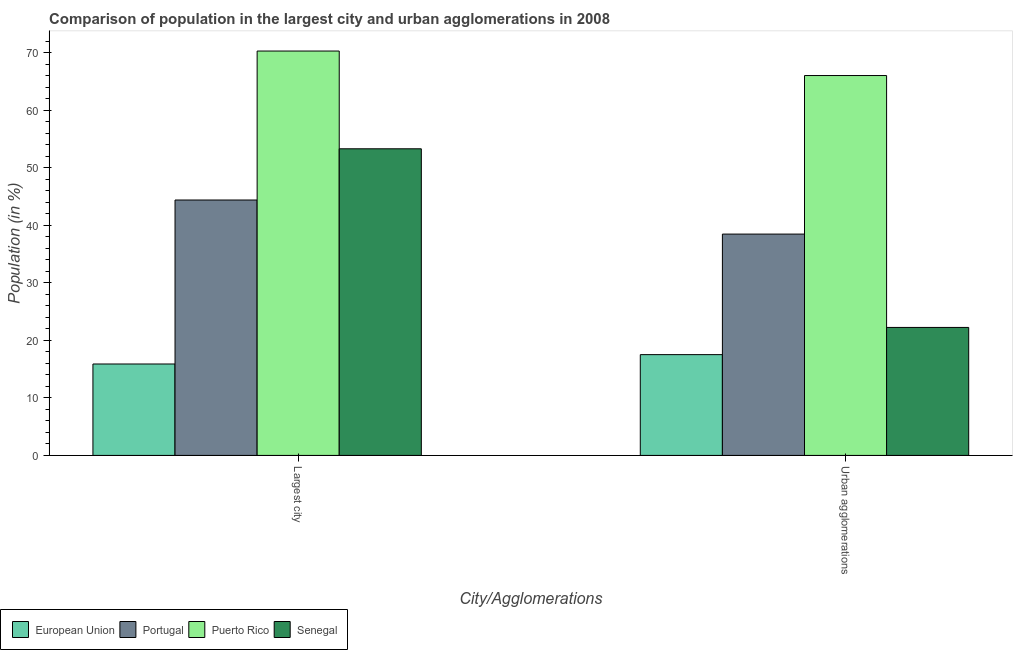How many different coloured bars are there?
Provide a succinct answer. 4. Are the number of bars per tick equal to the number of legend labels?
Keep it short and to the point. Yes. How many bars are there on the 1st tick from the left?
Ensure brevity in your answer.  4. What is the label of the 2nd group of bars from the left?
Provide a succinct answer. Urban agglomerations. What is the population in urban agglomerations in European Union?
Give a very brief answer. 17.52. Across all countries, what is the maximum population in the largest city?
Keep it short and to the point. 70.31. Across all countries, what is the minimum population in the largest city?
Provide a short and direct response. 15.9. In which country was the population in the largest city maximum?
Keep it short and to the point. Puerto Rico. What is the total population in urban agglomerations in the graph?
Offer a very short reply. 144.32. What is the difference between the population in urban agglomerations in Senegal and that in Portugal?
Keep it short and to the point. -16.23. What is the difference between the population in urban agglomerations in Senegal and the population in the largest city in European Union?
Offer a terse response. 6.36. What is the average population in urban agglomerations per country?
Your answer should be very brief. 36.08. What is the difference between the population in the largest city and population in urban agglomerations in Senegal?
Provide a short and direct response. 31.06. In how many countries, is the population in the largest city greater than 26 %?
Provide a succinct answer. 3. What is the ratio of the population in urban agglomerations in European Union to that in Portugal?
Your answer should be compact. 0.46. In how many countries, is the population in urban agglomerations greater than the average population in urban agglomerations taken over all countries?
Your answer should be compact. 2. What does the 1st bar from the right in Largest city represents?
Provide a succinct answer. Senegal. How many bars are there?
Ensure brevity in your answer.  8. Are all the bars in the graph horizontal?
Offer a terse response. No. What is the difference between two consecutive major ticks on the Y-axis?
Give a very brief answer. 10. Are the values on the major ticks of Y-axis written in scientific E-notation?
Provide a short and direct response. No. Does the graph contain any zero values?
Provide a short and direct response. No. What is the title of the graph?
Your response must be concise. Comparison of population in the largest city and urban agglomerations in 2008. What is the label or title of the X-axis?
Offer a very short reply. City/Agglomerations. What is the Population (in %) in European Union in Largest city?
Your answer should be compact. 15.9. What is the Population (in %) of Portugal in Largest city?
Offer a terse response. 44.41. What is the Population (in %) in Puerto Rico in Largest city?
Your answer should be very brief. 70.31. What is the Population (in %) in Senegal in Largest city?
Provide a short and direct response. 53.32. What is the Population (in %) in European Union in Urban agglomerations?
Offer a terse response. 17.52. What is the Population (in %) in Portugal in Urban agglomerations?
Provide a succinct answer. 38.49. What is the Population (in %) of Puerto Rico in Urban agglomerations?
Give a very brief answer. 66.05. What is the Population (in %) of Senegal in Urban agglomerations?
Your response must be concise. 22.25. Across all City/Agglomerations, what is the maximum Population (in %) in European Union?
Make the answer very short. 17.52. Across all City/Agglomerations, what is the maximum Population (in %) of Portugal?
Your response must be concise. 44.41. Across all City/Agglomerations, what is the maximum Population (in %) in Puerto Rico?
Your response must be concise. 70.31. Across all City/Agglomerations, what is the maximum Population (in %) in Senegal?
Your response must be concise. 53.32. Across all City/Agglomerations, what is the minimum Population (in %) of European Union?
Provide a short and direct response. 15.9. Across all City/Agglomerations, what is the minimum Population (in %) of Portugal?
Your response must be concise. 38.49. Across all City/Agglomerations, what is the minimum Population (in %) in Puerto Rico?
Your response must be concise. 66.05. Across all City/Agglomerations, what is the minimum Population (in %) in Senegal?
Your answer should be very brief. 22.25. What is the total Population (in %) of European Union in the graph?
Your answer should be compact. 33.42. What is the total Population (in %) of Portugal in the graph?
Your response must be concise. 82.9. What is the total Population (in %) in Puerto Rico in the graph?
Your answer should be compact. 136.36. What is the total Population (in %) of Senegal in the graph?
Keep it short and to the point. 75.57. What is the difference between the Population (in %) of European Union in Largest city and that in Urban agglomerations?
Offer a terse response. -1.63. What is the difference between the Population (in %) of Portugal in Largest city and that in Urban agglomerations?
Keep it short and to the point. 5.93. What is the difference between the Population (in %) of Puerto Rico in Largest city and that in Urban agglomerations?
Give a very brief answer. 4.26. What is the difference between the Population (in %) of Senegal in Largest city and that in Urban agglomerations?
Your answer should be compact. 31.06. What is the difference between the Population (in %) in European Union in Largest city and the Population (in %) in Portugal in Urban agglomerations?
Ensure brevity in your answer.  -22.59. What is the difference between the Population (in %) in European Union in Largest city and the Population (in %) in Puerto Rico in Urban agglomerations?
Ensure brevity in your answer.  -50.15. What is the difference between the Population (in %) in European Union in Largest city and the Population (in %) in Senegal in Urban agglomerations?
Make the answer very short. -6.36. What is the difference between the Population (in %) of Portugal in Largest city and the Population (in %) of Puerto Rico in Urban agglomerations?
Provide a succinct answer. -21.64. What is the difference between the Population (in %) in Portugal in Largest city and the Population (in %) in Senegal in Urban agglomerations?
Make the answer very short. 22.16. What is the difference between the Population (in %) of Puerto Rico in Largest city and the Population (in %) of Senegal in Urban agglomerations?
Keep it short and to the point. 48.06. What is the average Population (in %) of European Union per City/Agglomerations?
Offer a very short reply. 16.71. What is the average Population (in %) of Portugal per City/Agglomerations?
Offer a very short reply. 41.45. What is the average Population (in %) in Puerto Rico per City/Agglomerations?
Your response must be concise. 68.18. What is the average Population (in %) in Senegal per City/Agglomerations?
Provide a succinct answer. 37.78. What is the difference between the Population (in %) in European Union and Population (in %) in Portugal in Largest city?
Keep it short and to the point. -28.51. What is the difference between the Population (in %) in European Union and Population (in %) in Puerto Rico in Largest city?
Keep it short and to the point. -54.41. What is the difference between the Population (in %) in European Union and Population (in %) in Senegal in Largest city?
Provide a short and direct response. -37.42. What is the difference between the Population (in %) in Portugal and Population (in %) in Puerto Rico in Largest city?
Provide a succinct answer. -25.9. What is the difference between the Population (in %) of Portugal and Population (in %) of Senegal in Largest city?
Ensure brevity in your answer.  -8.9. What is the difference between the Population (in %) of Puerto Rico and Population (in %) of Senegal in Largest city?
Keep it short and to the point. 17. What is the difference between the Population (in %) of European Union and Population (in %) of Portugal in Urban agglomerations?
Ensure brevity in your answer.  -20.96. What is the difference between the Population (in %) in European Union and Population (in %) in Puerto Rico in Urban agglomerations?
Provide a succinct answer. -48.53. What is the difference between the Population (in %) in European Union and Population (in %) in Senegal in Urban agglomerations?
Keep it short and to the point. -4.73. What is the difference between the Population (in %) of Portugal and Population (in %) of Puerto Rico in Urban agglomerations?
Provide a succinct answer. -27.57. What is the difference between the Population (in %) in Portugal and Population (in %) in Senegal in Urban agglomerations?
Your answer should be compact. 16.23. What is the difference between the Population (in %) in Puerto Rico and Population (in %) in Senegal in Urban agglomerations?
Your answer should be compact. 43.8. What is the ratio of the Population (in %) in European Union in Largest city to that in Urban agglomerations?
Ensure brevity in your answer.  0.91. What is the ratio of the Population (in %) in Portugal in Largest city to that in Urban agglomerations?
Offer a very short reply. 1.15. What is the ratio of the Population (in %) in Puerto Rico in Largest city to that in Urban agglomerations?
Give a very brief answer. 1.06. What is the ratio of the Population (in %) in Senegal in Largest city to that in Urban agglomerations?
Your response must be concise. 2.4. What is the difference between the highest and the second highest Population (in %) of European Union?
Make the answer very short. 1.63. What is the difference between the highest and the second highest Population (in %) of Portugal?
Your answer should be compact. 5.93. What is the difference between the highest and the second highest Population (in %) in Puerto Rico?
Your response must be concise. 4.26. What is the difference between the highest and the second highest Population (in %) of Senegal?
Offer a terse response. 31.06. What is the difference between the highest and the lowest Population (in %) in European Union?
Your response must be concise. 1.63. What is the difference between the highest and the lowest Population (in %) in Portugal?
Give a very brief answer. 5.93. What is the difference between the highest and the lowest Population (in %) of Puerto Rico?
Provide a succinct answer. 4.26. What is the difference between the highest and the lowest Population (in %) in Senegal?
Give a very brief answer. 31.06. 